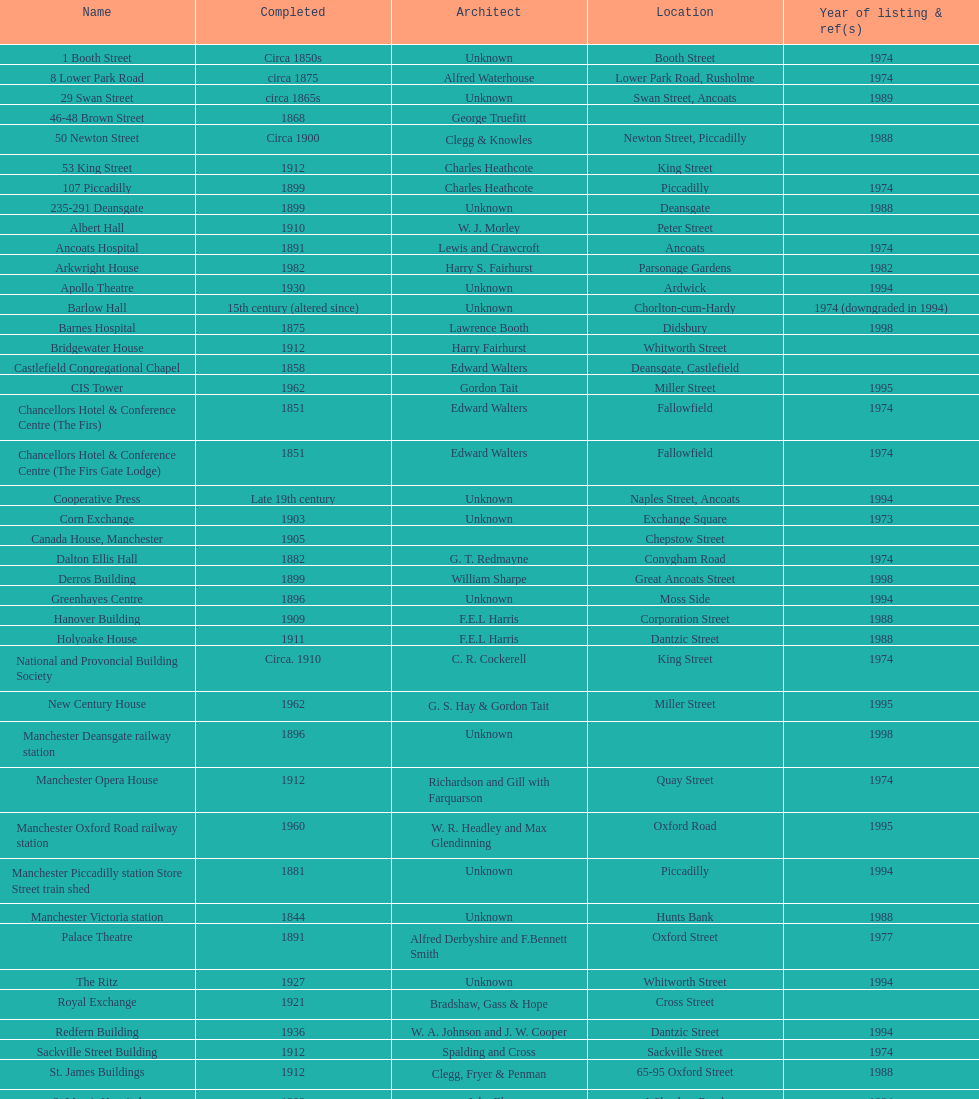How many constructions share the same year of listing as 1974? 15. 